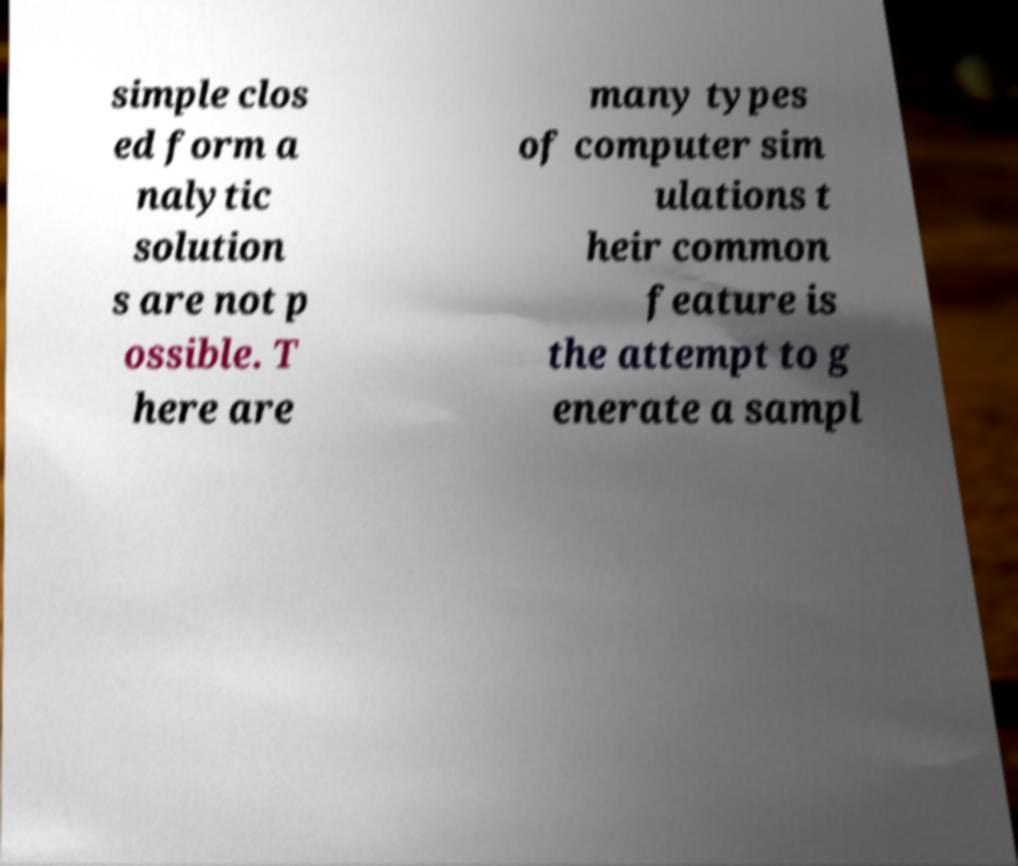Could you extract and type out the text from this image? simple clos ed form a nalytic solution s are not p ossible. T here are many types of computer sim ulations t heir common feature is the attempt to g enerate a sampl 